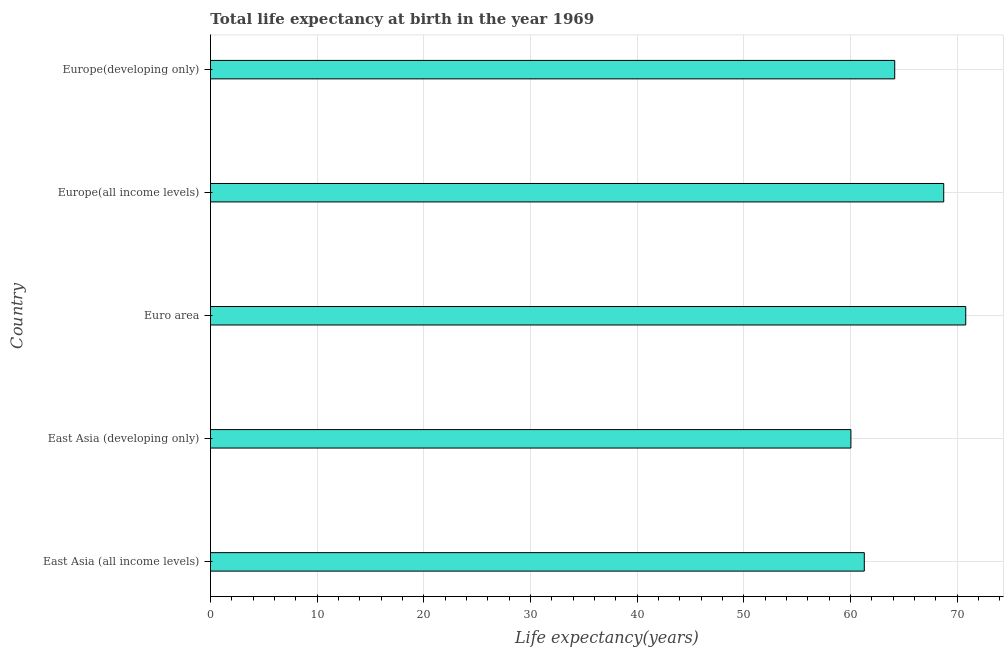Does the graph contain grids?
Offer a very short reply. Yes. What is the title of the graph?
Your response must be concise. Total life expectancy at birth in the year 1969. What is the label or title of the X-axis?
Make the answer very short. Life expectancy(years). What is the label or title of the Y-axis?
Provide a short and direct response. Country. What is the life expectancy at birth in East Asia (all income levels)?
Keep it short and to the point. 61.28. Across all countries, what is the maximum life expectancy at birth?
Provide a succinct answer. 70.79. Across all countries, what is the minimum life expectancy at birth?
Your answer should be very brief. 60.03. In which country was the life expectancy at birth minimum?
Give a very brief answer. East Asia (developing only). What is the sum of the life expectancy at birth?
Provide a short and direct response. 324.97. What is the difference between the life expectancy at birth in East Asia (developing only) and Euro area?
Make the answer very short. -10.76. What is the average life expectancy at birth per country?
Your response must be concise. 65. What is the median life expectancy at birth?
Offer a terse response. 64.14. In how many countries, is the life expectancy at birth greater than 66 years?
Provide a short and direct response. 2. What is the ratio of the life expectancy at birth in Euro area to that in Europe(developing only)?
Make the answer very short. 1.1. Is the life expectancy at birth in East Asia (all income levels) less than that in Europe(all income levels)?
Ensure brevity in your answer.  Yes. What is the difference between the highest and the second highest life expectancy at birth?
Give a very brief answer. 2.06. What is the difference between the highest and the lowest life expectancy at birth?
Make the answer very short. 10.76. What is the difference between two consecutive major ticks on the X-axis?
Provide a short and direct response. 10. What is the Life expectancy(years) of East Asia (all income levels)?
Keep it short and to the point. 61.28. What is the Life expectancy(years) of East Asia (developing only)?
Make the answer very short. 60.03. What is the Life expectancy(years) in Euro area?
Your response must be concise. 70.79. What is the Life expectancy(years) of Europe(all income levels)?
Your answer should be compact. 68.73. What is the Life expectancy(years) in Europe(developing only)?
Keep it short and to the point. 64.14. What is the difference between the Life expectancy(years) in East Asia (all income levels) and East Asia (developing only)?
Make the answer very short. 1.25. What is the difference between the Life expectancy(years) in East Asia (all income levels) and Euro area?
Keep it short and to the point. -9.51. What is the difference between the Life expectancy(years) in East Asia (all income levels) and Europe(all income levels)?
Give a very brief answer. -7.44. What is the difference between the Life expectancy(years) in East Asia (all income levels) and Europe(developing only)?
Your answer should be very brief. -2.85. What is the difference between the Life expectancy(years) in East Asia (developing only) and Euro area?
Offer a terse response. -10.76. What is the difference between the Life expectancy(years) in East Asia (developing only) and Europe(all income levels)?
Give a very brief answer. -8.7. What is the difference between the Life expectancy(years) in East Asia (developing only) and Europe(developing only)?
Keep it short and to the point. -4.11. What is the difference between the Life expectancy(years) in Euro area and Europe(all income levels)?
Provide a short and direct response. 2.06. What is the difference between the Life expectancy(years) in Euro area and Europe(developing only)?
Ensure brevity in your answer.  6.66. What is the difference between the Life expectancy(years) in Europe(all income levels) and Europe(developing only)?
Provide a succinct answer. 4.59. What is the ratio of the Life expectancy(years) in East Asia (all income levels) to that in East Asia (developing only)?
Your answer should be very brief. 1.02. What is the ratio of the Life expectancy(years) in East Asia (all income levels) to that in Euro area?
Offer a terse response. 0.87. What is the ratio of the Life expectancy(years) in East Asia (all income levels) to that in Europe(all income levels)?
Offer a very short reply. 0.89. What is the ratio of the Life expectancy(years) in East Asia (all income levels) to that in Europe(developing only)?
Offer a very short reply. 0.96. What is the ratio of the Life expectancy(years) in East Asia (developing only) to that in Euro area?
Your response must be concise. 0.85. What is the ratio of the Life expectancy(years) in East Asia (developing only) to that in Europe(all income levels)?
Provide a short and direct response. 0.87. What is the ratio of the Life expectancy(years) in East Asia (developing only) to that in Europe(developing only)?
Your answer should be compact. 0.94. What is the ratio of the Life expectancy(years) in Euro area to that in Europe(developing only)?
Give a very brief answer. 1.1. What is the ratio of the Life expectancy(years) in Europe(all income levels) to that in Europe(developing only)?
Your response must be concise. 1.07. 